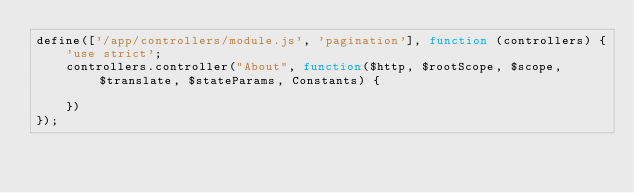Convert code to text. <code><loc_0><loc_0><loc_500><loc_500><_JavaScript_>define(['/app/controllers/module.js', 'pagination'], function (controllers) {
	'use strict';
    controllers.controller("About", function($http, $rootScope, $scope, $translate, $stateParams, Constants) {

	})
});
</code> 